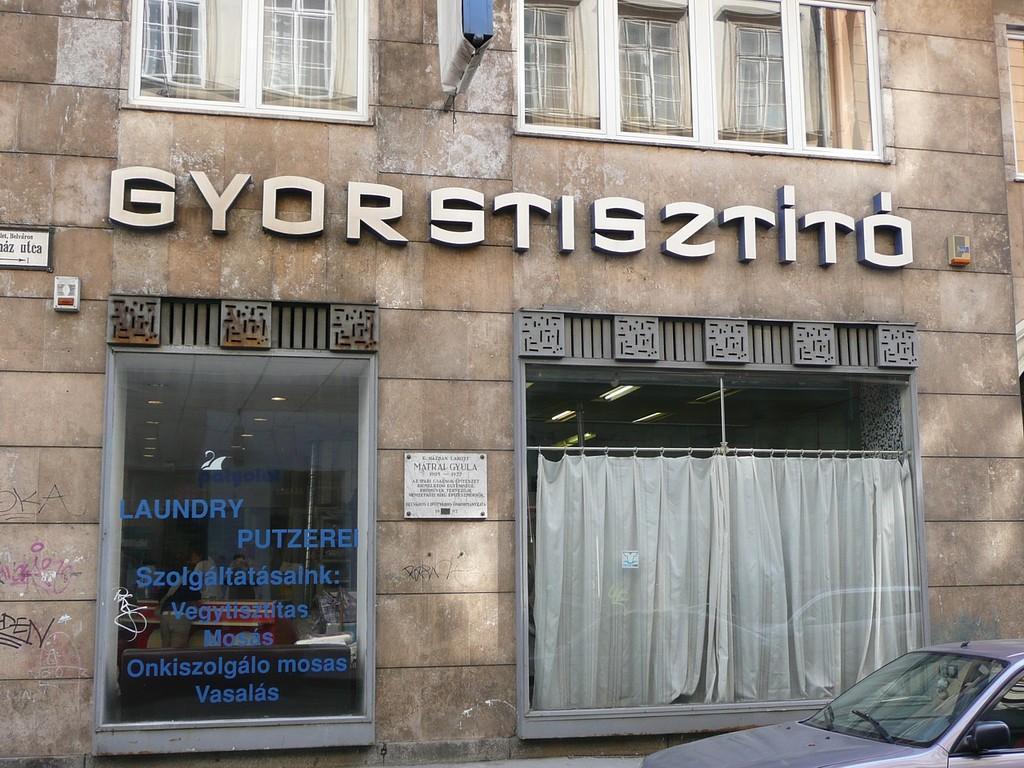How would you summarize this image in a sentence or two? In this picture we can see a car in the bottom right. We can see some text, glass objects, windows and other objects on a building. Through these glass objects, we can see a few people, curtains and other objects in the building. 